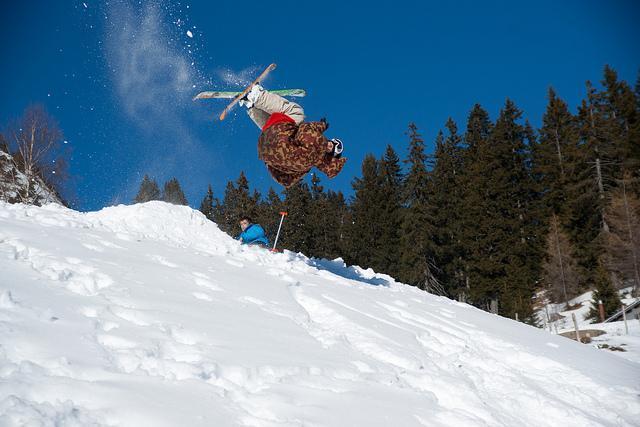How many people can be seen?
Give a very brief answer. 1. 